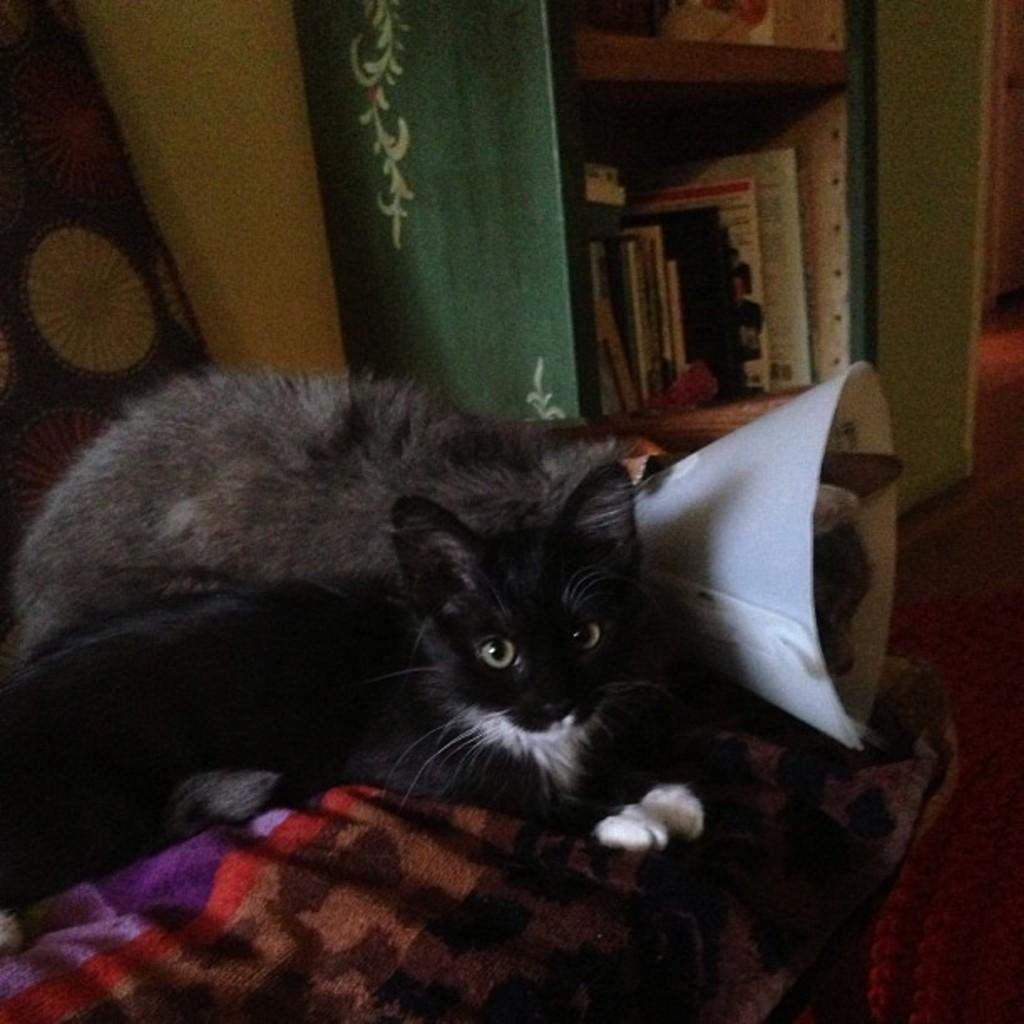How many cats can be seen in the image? There are two cats in the image. What are the cats sitting on? The cats are on an object covered with a cloth. What can be seen in the background of the image? There are books arranged on a shelf in the background of the image. What flavor of question is being asked by the cats in the image? There are no questions being asked by the cats in the image, and therefore no flavor can be determined. 